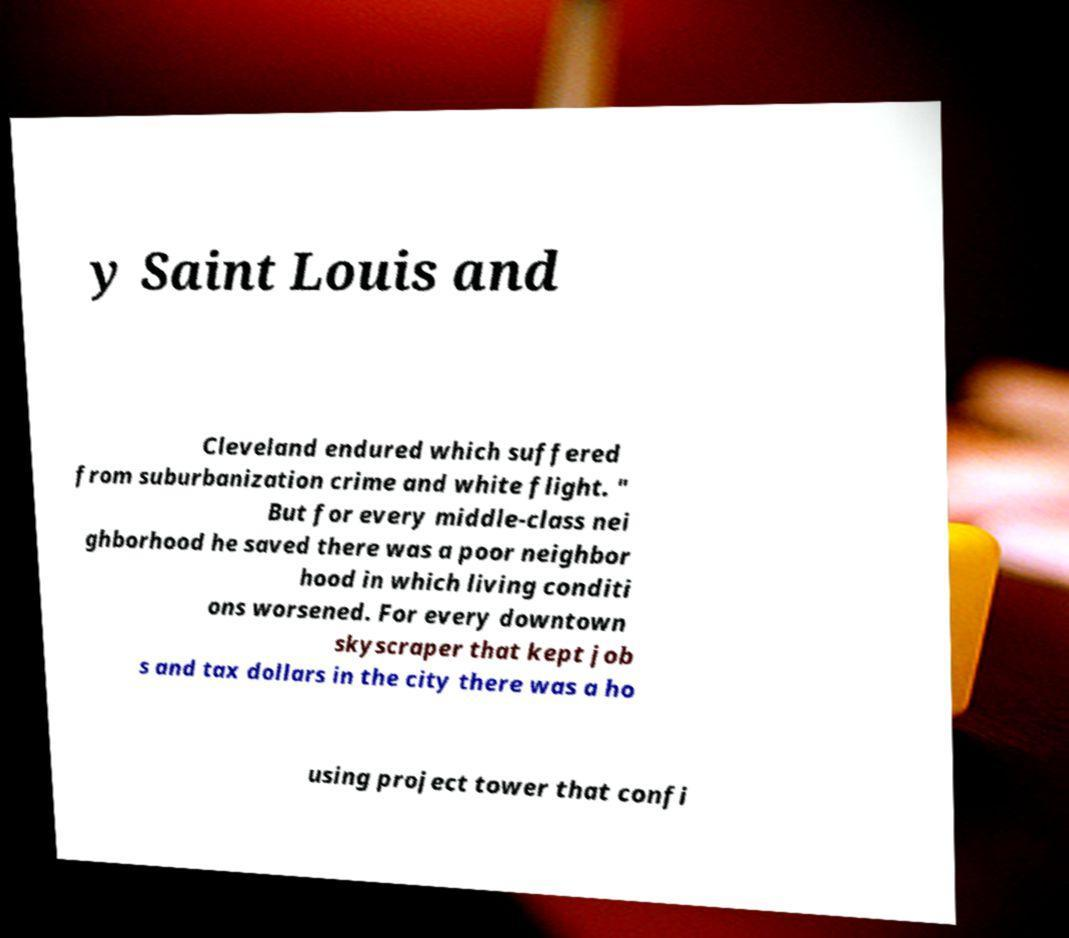Please read and relay the text visible in this image. What does it say? y Saint Louis and Cleveland endured which suffered from suburbanization crime and white flight. " But for every middle-class nei ghborhood he saved there was a poor neighbor hood in which living conditi ons worsened. For every downtown skyscraper that kept job s and tax dollars in the city there was a ho using project tower that confi 